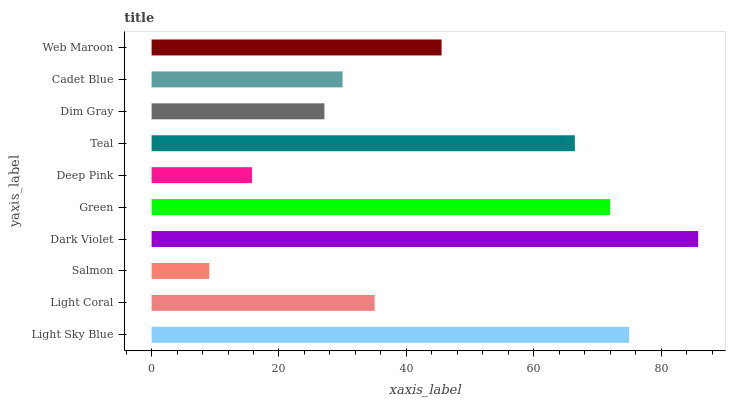Is Salmon the minimum?
Answer yes or no. Yes. Is Dark Violet the maximum?
Answer yes or no. Yes. Is Light Coral the minimum?
Answer yes or no. No. Is Light Coral the maximum?
Answer yes or no. No. Is Light Sky Blue greater than Light Coral?
Answer yes or no. Yes. Is Light Coral less than Light Sky Blue?
Answer yes or no. Yes. Is Light Coral greater than Light Sky Blue?
Answer yes or no. No. Is Light Sky Blue less than Light Coral?
Answer yes or no. No. Is Web Maroon the high median?
Answer yes or no. Yes. Is Light Coral the low median?
Answer yes or no. Yes. Is Teal the high median?
Answer yes or no. No. Is Dark Violet the low median?
Answer yes or no. No. 